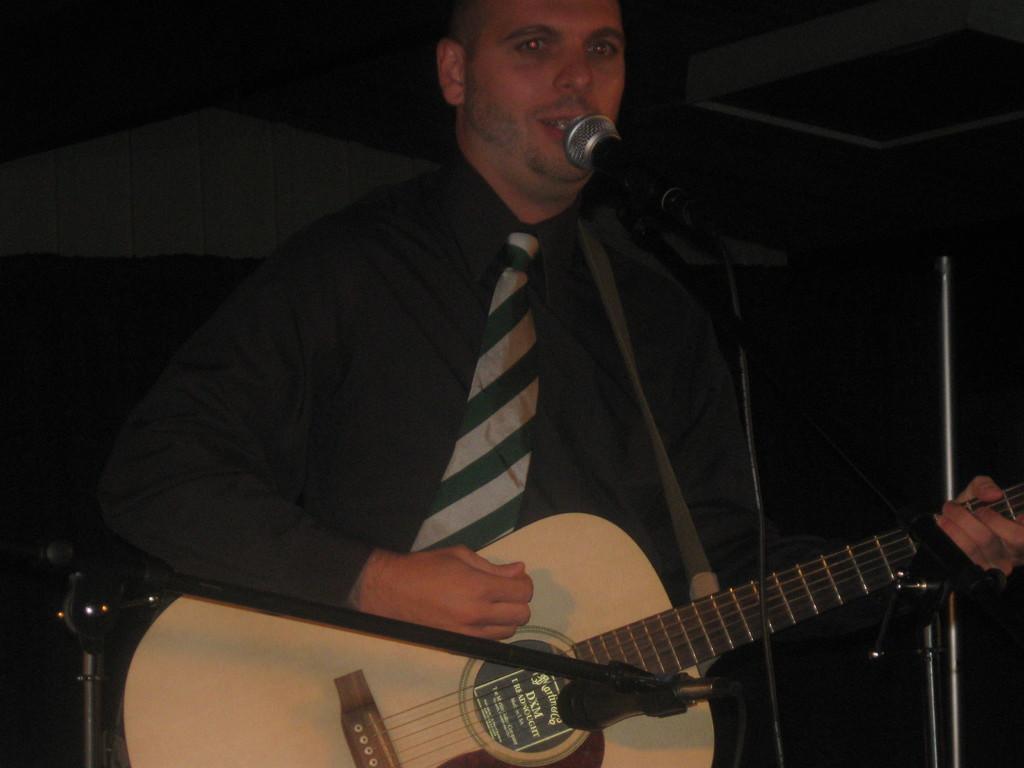Can you describe this image briefly? As we can see in the image there is a man holding guitar and singing a song on mic. 